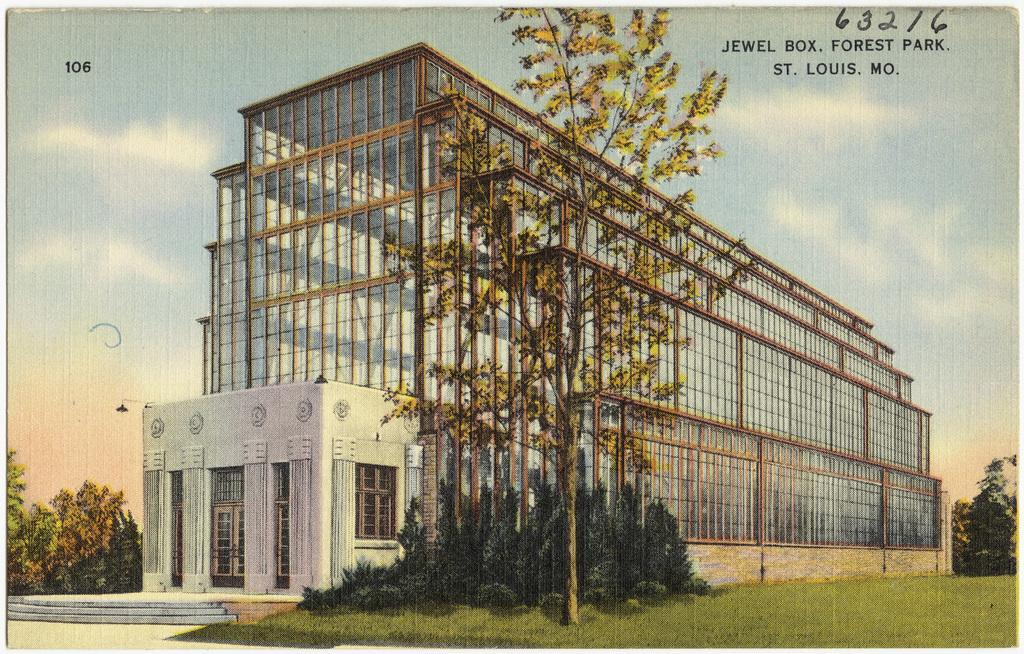What type of artwork is depicted in the image? The image is a painting. What structures can be seen in the painting? There are buildings in the image. What type of vegetation is present at the bottom of the painting? There are trees at the bottom of the image. What is visible in the background of the painting? There is sky visible in the background of the image. How does the painting burn in the image? The painting does not burn in the image; it is a static, two-dimensional representation. 